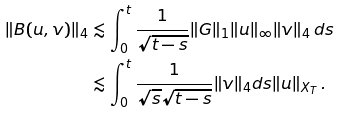Convert formula to latex. <formula><loc_0><loc_0><loc_500><loc_500>\| B ( u , v ) \| _ { 4 } & \lesssim \int _ { 0 } ^ { t } \frac { 1 } { \sqrt { t - s } } \| G \| _ { 1 } \| u \| _ { \infty } \| v \| _ { 4 } \, d s \\ & \lesssim \int _ { 0 } ^ { t } \frac { 1 } { \sqrt { s } \sqrt { t - s } } \| v \| _ { 4 } d s \| u \| _ { X _ { T } } \, .</formula> 